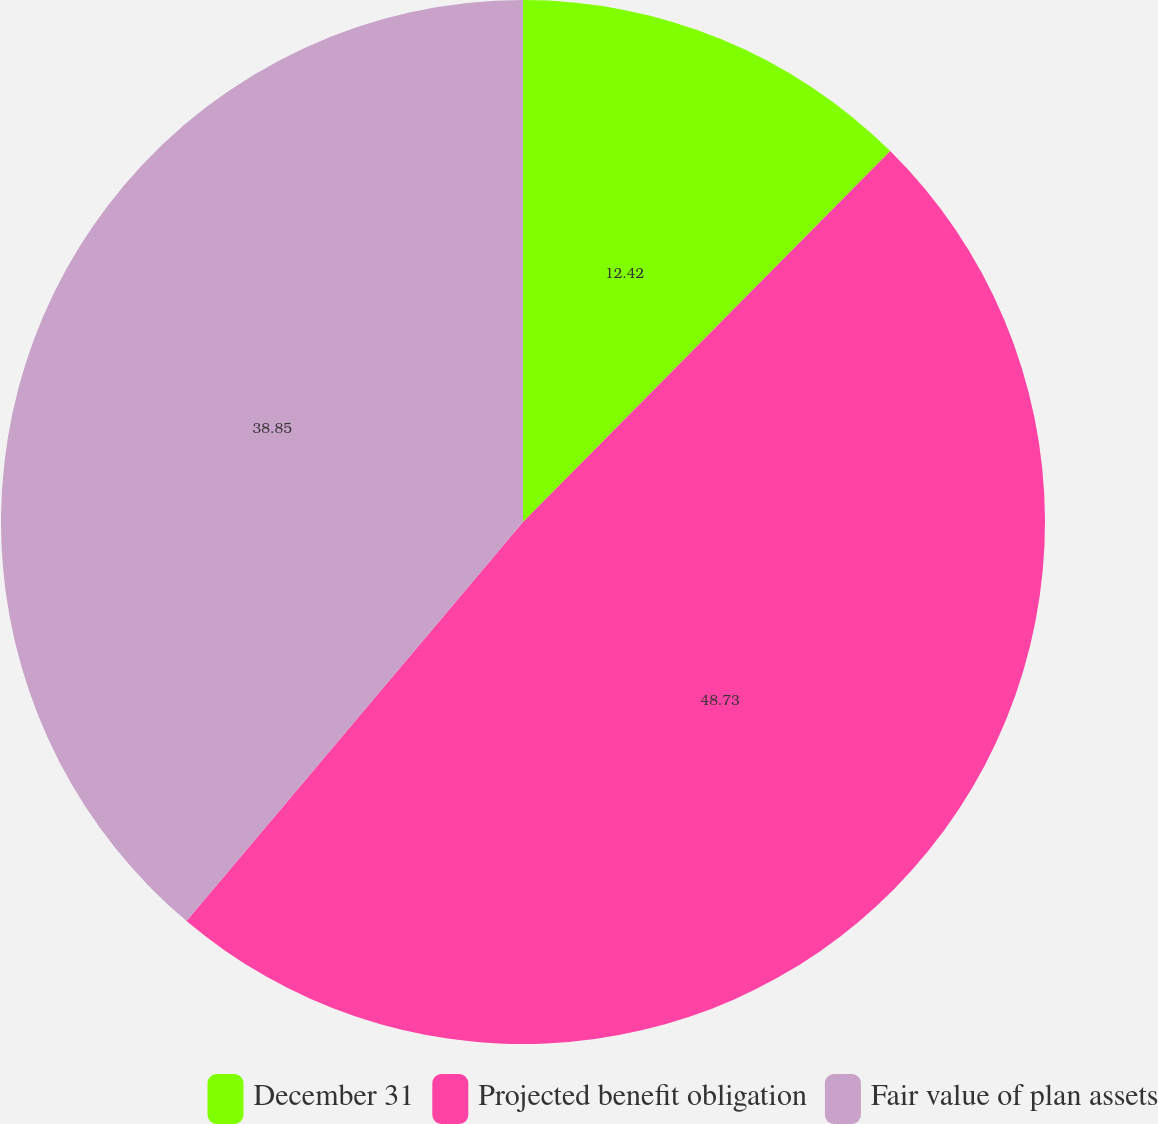<chart> <loc_0><loc_0><loc_500><loc_500><pie_chart><fcel>December 31<fcel>Projected benefit obligation<fcel>Fair value of plan assets<nl><fcel>12.42%<fcel>48.73%<fcel>38.85%<nl></chart> 